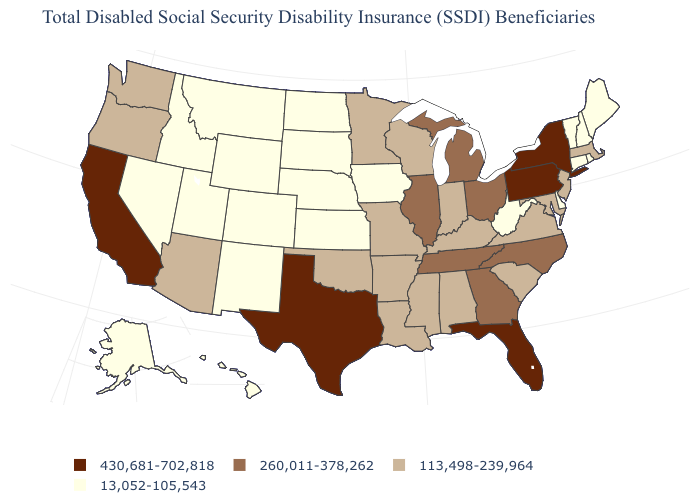Which states hav the highest value in the West?
Keep it brief. California. What is the value of Michigan?
Answer briefly. 260,011-378,262. What is the value of Hawaii?
Concise answer only. 13,052-105,543. Name the states that have a value in the range 13,052-105,543?
Keep it brief. Alaska, Colorado, Connecticut, Delaware, Hawaii, Idaho, Iowa, Kansas, Maine, Montana, Nebraska, Nevada, New Hampshire, New Mexico, North Dakota, Rhode Island, South Dakota, Utah, Vermont, West Virginia, Wyoming. Name the states that have a value in the range 13,052-105,543?
Keep it brief. Alaska, Colorado, Connecticut, Delaware, Hawaii, Idaho, Iowa, Kansas, Maine, Montana, Nebraska, Nevada, New Hampshire, New Mexico, North Dakota, Rhode Island, South Dakota, Utah, Vermont, West Virginia, Wyoming. Which states have the highest value in the USA?
Write a very short answer. California, Florida, New York, Pennsylvania, Texas. Which states have the highest value in the USA?
Concise answer only. California, Florida, New York, Pennsylvania, Texas. What is the value of Minnesota?
Keep it brief. 113,498-239,964. Which states hav the highest value in the South?
Quick response, please. Florida, Texas. Among the states that border Vermont , does New York have the lowest value?
Be succinct. No. What is the lowest value in states that border North Dakota?
Answer briefly. 13,052-105,543. Which states have the lowest value in the USA?
Answer briefly. Alaska, Colorado, Connecticut, Delaware, Hawaii, Idaho, Iowa, Kansas, Maine, Montana, Nebraska, Nevada, New Hampshire, New Mexico, North Dakota, Rhode Island, South Dakota, Utah, Vermont, West Virginia, Wyoming. What is the value of North Dakota?
Quick response, please. 13,052-105,543. Among the states that border Missouri , does Kentucky have the highest value?
Concise answer only. No. 